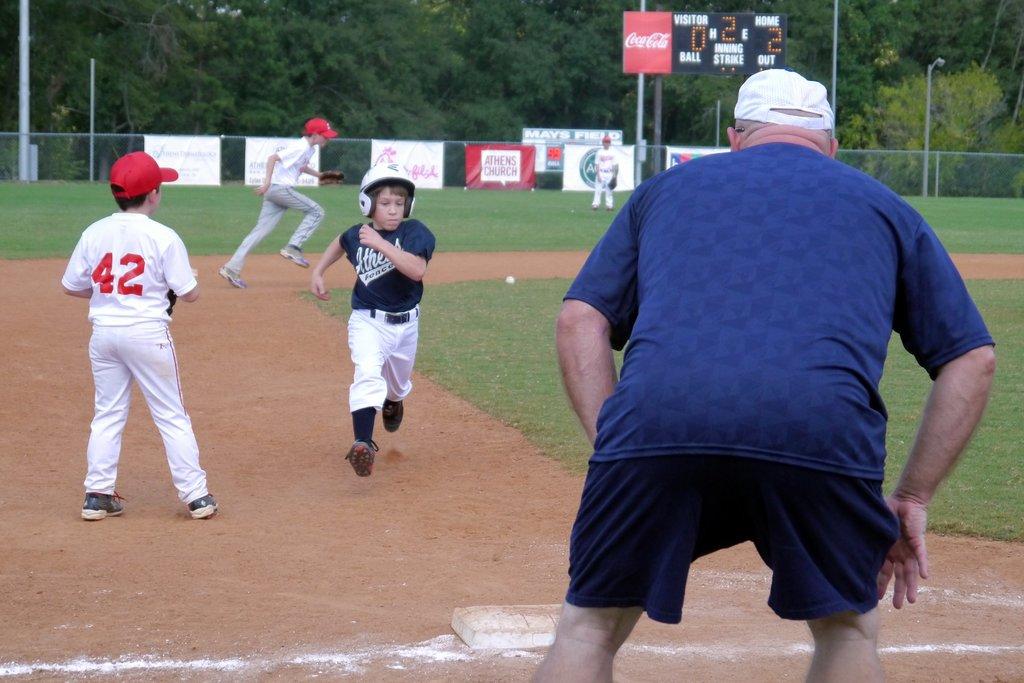What number is on the back of the player in the white uniform?
Keep it short and to the point. 42. What number is shower in the middle of the scoreboard?
Your response must be concise. 2. 